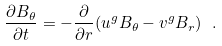Convert formula to latex. <formula><loc_0><loc_0><loc_500><loc_500>\frac { \partial B _ { \theta } } { \partial t } = - \frac { \partial } { \partial r } ( u ^ { g } B _ { \theta } - v ^ { g } B _ { r } ) \ .</formula> 